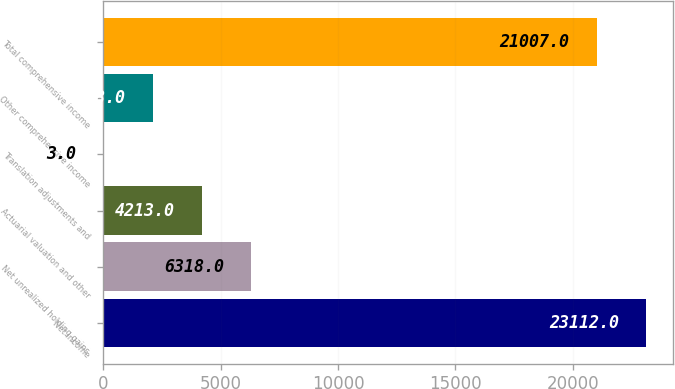Convert chart to OTSL. <chart><loc_0><loc_0><loc_500><loc_500><bar_chart><fcel>Net income<fcel>Net unrealized holding gains<fcel>Actuarial valuation and other<fcel>Translation adjustments and<fcel>Other comprehensive income<fcel>Total comprehensive income<nl><fcel>23112<fcel>6318<fcel>4213<fcel>3<fcel>2108<fcel>21007<nl></chart> 